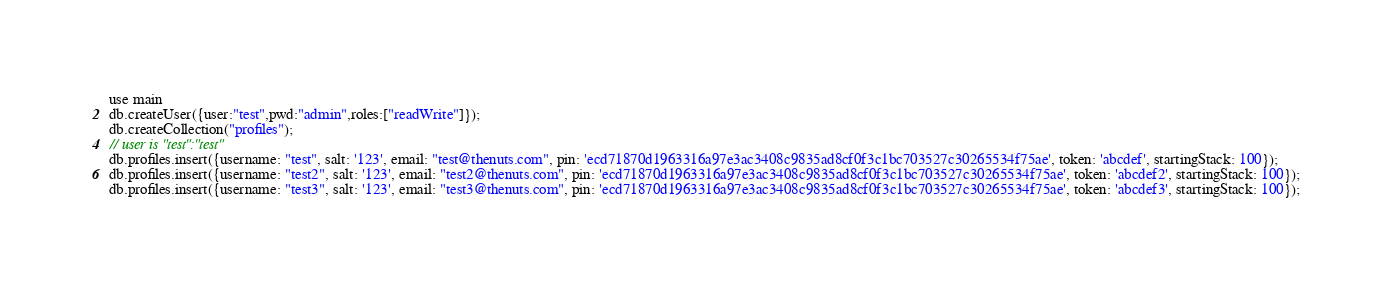<code> <loc_0><loc_0><loc_500><loc_500><_JavaScript_>use main
db.createUser({user:"test",pwd:"admin",roles:["readWrite"]});
db.createCollection("profiles");
// user is "test":"test"
db.profiles.insert({username: "test", salt: '123', email: "test@thenuts.com", pin: 'ecd71870d1963316a97e3ac3408c9835ad8cf0f3c1bc703527c30265534f75ae', token: 'abcdef', startingStack: 100});
db.profiles.insert({username: "test2", salt: '123', email: "test2@thenuts.com", pin: 'ecd71870d1963316a97e3ac3408c9835ad8cf0f3c1bc703527c30265534f75ae', token: 'abcdef2', startingStack: 100});
db.profiles.insert({username: "test3", salt: '123', email: "test3@thenuts.com", pin: 'ecd71870d1963316a97e3ac3408c9835ad8cf0f3c1bc703527c30265534f75ae', token: 'abcdef3', startingStack: 100});
</code> 